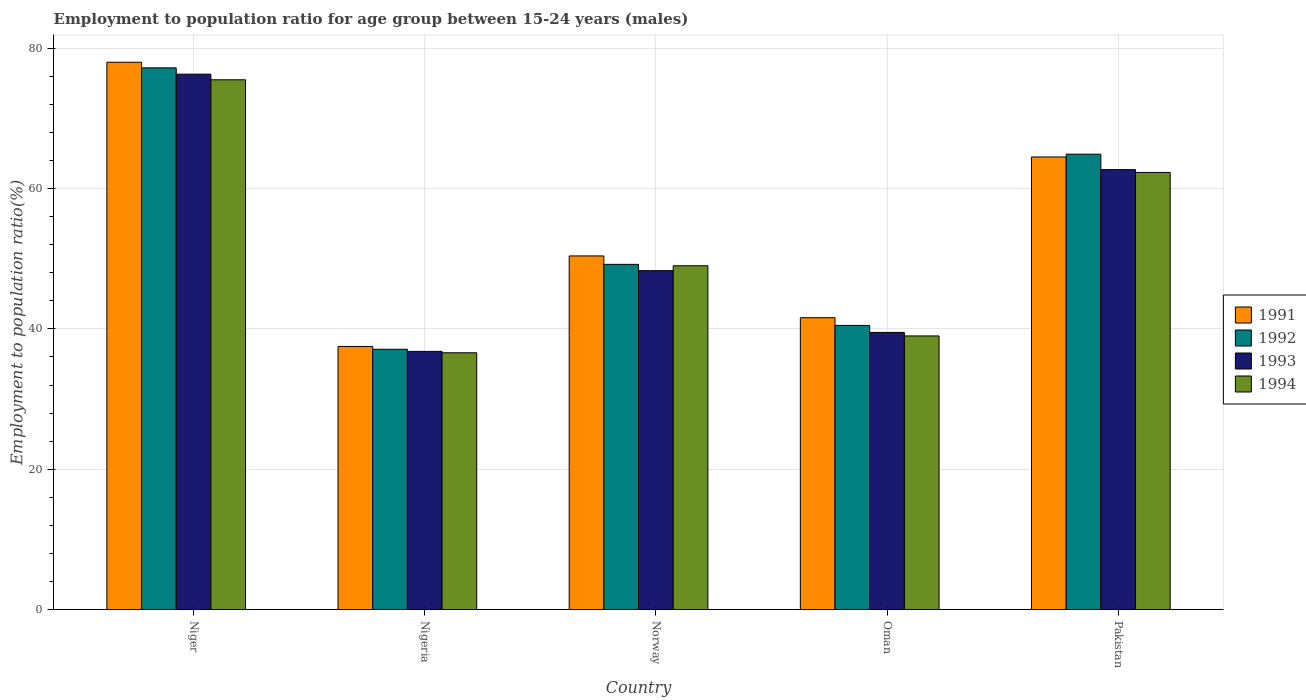How many different coloured bars are there?
Your answer should be very brief. 4. How many groups of bars are there?
Make the answer very short. 5. What is the label of the 4th group of bars from the left?
Offer a terse response. Oman. In how many cases, is the number of bars for a given country not equal to the number of legend labels?
Provide a succinct answer. 0. What is the employment to population ratio in 1992 in Niger?
Ensure brevity in your answer.  77.2. Across all countries, what is the maximum employment to population ratio in 1994?
Your answer should be compact. 75.5. Across all countries, what is the minimum employment to population ratio in 1994?
Make the answer very short. 36.6. In which country was the employment to population ratio in 1992 maximum?
Ensure brevity in your answer.  Niger. In which country was the employment to population ratio in 1991 minimum?
Your answer should be very brief. Nigeria. What is the total employment to population ratio in 1991 in the graph?
Your response must be concise. 272. What is the difference between the employment to population ratio in 1993 in Nigeria and that in Oman?
Make the answer very short. -2.7. What is the difference between the employment to population ratio in 1994 in Pakistan and the employment to population ratio in 1991 in Niger?
Keep it short and to the point. -15.7. What is the average employment to population ratio in 1992 per country?
Your answer should be compact. 53.78. What is the difference between the employment to population ratio of/in 1994 and employment to population ratio of/in 1991 in Nigeria?
Keep it short and to the point. -0.9. What is the ratio of the employment to population ratio in 1992 in Nigeria to that in Pakistan?
Your answer should be very brief. 0.57. Is the employment to population ratio in 1994 in Oman less than that in Pakistan?
Offer a terse response. Yes. What is the difference between the highest and the second highest employment to population ratio in 1993?
Your answer should be very brief. -28. What is the difference between the highest and the lowest employment to population ratio in 1992?
Your answer should be very brief. 40.1. Is it the case that in every country, the sum of the employment to population ratio in 1991 and employment to population ratio in 1993 is greater than the sum of employment to population ratio in 1992 and employment to population ratio in 1994?
Offer a very short reply. No. What does the 3rd bar from the left in Pakistan represents?
Give a very brief answer. 1993. Is it the case that in every country, the sum of the employment to population ratio in 1991 and employment to population ratio in 1993 is greater than the employment to population ratio in 1994?
Your answer should be very brief. Yes. Are all the bars in the graph horizontal?
Make the answer very short. No. How many countries are there in the graph?
Your answer should be very brief. 5. What is the difference between two consecutive major ticks on the Y-axis?
Offer a terse response. 20. Where does the legend appear in the graph?
Provide a short and direct response. Center right. How many legend labels are there?
Give a very brief answer. 4. What is the title of the graph?
Your answer should be compact. Employment to population ratio for age group between 15-24 years (males). What is the label or title of the X-axis?
Give a very brief answer. Country. What is the Employment to population ratio(%) of 1992 in Niger?
Ensure brevity in your answer.  77.2. What is the Employment to population ratio(%) of 1993 in Niger?
Your answer should be very brief. 76.3. What is the Employment to population ratio(%) in 1994 in Niger?
Give a very brief answer. 75.5. What is the Employment to population ratio(%) of 1991 in Nigeria?
Keep it short and to the point. 37.5. What is the Employment to population ratio(%) of 1992 in Nigeria?
Offer a terse response. 37.1. What is the Employment to population ratio(%) in 1993 in Nigeria?
Provide a succinct answer. 36.8. What is the Employment to population ratio(%) in 1994 in Nigeria?
Your answer should be very brief. 36.6. What is the Employment to population ratio(%) of 1991 in Norway?
Your response must be concise. 50.4. What is the Employment to population ratio(%) of 1992 in Norway?
Ensure brevity in your answer.  49.2. What is the Employment to population ratio(%) of 1993 in Norway?
Your answer should be compact. 48.3. What is the Employment to population ratio(%) of 1991 in Oman?
Provide a succinct answer. 41.6. What is the Employment to population ratio(%) of 1992 in Oman?
Keep it short and to the point. 40.5. What is the Employment to population ratio(%) in 1993 in Oman?
Provide a short and direct response. 39.5. What is the Employment to population ratio(%) in 1994 in Oman?
Offer a very short reply. 39. What is the Employment to population ratio(%) of 1991 in Pakistan?
Your response must be concise. 64.5. What is the Employment to population ratio(%) in 1992 in Pakistan?
Keep it short and to the point. 64.9. What is the Employment to population ratio(%) in 1993 in Pakistan?
Give a very brief answer. 62.7. What is the Employment to population ratio(%) in 1994 in Pakistan?
Your response must be concise. 62.3. Across all countries, what is the maximum Employment to population ratio(%) in 1991?
Offer a terse response. 78. Across all countries, what is the maximum Employment to population ratio(%) in 1992?
Provide a succinct answer. 77.2. Across all countries, what is the maximum Employment to population ratio(%) of 1993?
Provide a short and direct response. 76.3. Across all countries, what is the maximum Employment to population ratio(%) of 1994?
Keep it short and to the point. 75.5. Across all countries, what is the minimum Employment to population ratio(%) in 1991?
Your answer should be very brief. 37.5. Across all countries, what is the minimum Employment to population ratio(%) of 1992?
Ensure brevity in your answer.  37.1. Across all countries, what is the minimum Employment to population ratio(%) of 1993?
Make the answer very short. 36.8. Across all countries, what is the minimum Employment to population ratio(%) of 1994?
Offer a terse response. 36.6. What is the total Employment to population ratio(%) of 1991 in the graph?
Make the answer very short. 272. What is the total Employment to population ratio(%) of 1992 in the graph?
Provide a short and direct response. 268.9. What is the total Employment to population ratio(%) of 1993 in the graph?
Your response must be concise. 263.6. What is the total Employment to population ratio(%) of 1994 in the graph?
Keep it short and to the point. 262.4. What is the difference between the Employment to population ratio(%) in 1991 in Niger and that in Nigeria?
Your answer should be very brief. 40.5. What is the difference between the Employment to population ratio(%) of 1992 in Niger and that in Nigeria?
Provide a short and direct response. 40.1. What is the difference between the Employment to population ratio(%) of 1993 in Niger and that in Nigeria?
Your answer should be compact. 39.5. What is the difference between the Employment to population ratio(%) of 1994 in Niger and that in Nigeria?
Offer a very short reply. 38.9. What is the difference between the Employment to population ratio(%) in 1991 in Niger and that in Norway?
Offer a very short reply. 27.6. What is the difference between the Employment to population ratio(%) of 1992 in Niger and that in Norway?
Provide a short and direct response. 28. What is the difference between the Employment to population ratio(%) of 1993 in Niger and that in Norway?
Your answer should be very brief. 28. What is the difference between the Employment to population ratio(%) in 1994 in Niger and that in Norway?
Offer a very short reply. 26.5. What is the difference between the Employment to population ratio(%) in 1991 in Niger and that in Oman?
Ensure brevity in your answer.  36.4. What is the difference between the Employment to population ratio(%) of 1992 in Niger and that in Oman?
Provide a succinct answer. 36.7. What is the difference between the Employment to population ratio(%) in 1993 in Niger and that in Oman?
Offer a very short reply. 36.8. What is the difference between the Employment to population ratio(%) in 1994 in Niger and that in Oman?
Offer a very short reply. 36.5. What is the difference between the Employment to population ratio(%) in 1992 in Niger and that in Pakistan?
Offer a terse response. 12.3. What is the difference between the Employment to population ratio(%) in 1994 in Niger and that in Pakistan?
Keep it short and to the point. 13.2. What is the difference between the Employment to population ratio(%) of 1992 in Nigeria and that in Norway?
Your response must be concise. -12.1. What is the difference between the Employment to population ratio(%) of 1994 in Nigeria and that in Norway?
Make the answer very short. -12.4. What is the difference between the Employment to population ratio(%) of 1992 in Nigeria and that in Oman?
Your answer should be compact. -3.4. What is the difference between the Employment to population ratio(%) in 1994 in Nigeria and that in Oman?
Ensure brevity in your answer.  -2.4. What is the difference between the Employment to population ratio(%) of 1992 in Nigeria and that in Pakistan?
Your answer should be very brief. -27.8. What is the difference between the Employment to population ratio(%) of 1993 in Nigeria and that in Pakistan?
Give a very brief answer. -25.9. What is the difference between the Employment to population ratio(%) in 1994 in Nigeria and that in Pakistan?
Keep it short and to the point. -25.7. What is the difference between the Employment to population ratio(%) in 1992 in Norway and that in Oman?
Offer a terse response. 8.7. What is the difference between the Employment to population ratio(%) in 1993 in Norway and that in Oman?
Make the answer very short. 8.8. What is the difference between the Employment to population ratio(%) of 1994 in Norway and that in Oman?
Your response must be concise. 10. What is the difference between the Employment to population ratio(%) of 1991 in Norway and that in Pakistan?
Keep it short and to the point. -14.1. What is the difference between the Employment to population ratio(%) of 1992 in Norway and that in Pakistan?
Provide a succinct answer. -15.7. What is the difference between the Employment to population ratio(%) of 1993 in Norway and that in Pakistan?
Offer a very short reply. -14.4. What is the difference between the Employment to population ratio(%) in 1994 in Norway and that in Pakistan?
Ensure brevity in your answer.  -13.3. What is the difference between the Employment to population ratio(%) of 1991 in Oman and that in Pakistan?
Make the answer very short. -22.9. What is the difference between the Employment to population ratio(%) in 1992 in Oman and that in Pakistan?
Your response must be concise. -24.4. What is the difference between the Employment to population ratio(%) in 1993 in Oman and that in Pakistan?
Provide a succinct answer. -23.2. What is the difference between the Employment to population ratio(%) of 1994 in Oman and that in Pakistan?
Your response must be concise. -23.3. What is the difference between the Employment to population ratio(%) of 1991 in Niger and the Employment to population ratio(%) of 1992 in Nigeria?
Offer a terse response. 40.9. What is the difference between the Employment to population ratio(%) in 1991 in Niger and the Employment to population ratio(%) in 1993 in Nigeria?
Keep it short and to the point. 41.2. What is the difference between the Employment to population ratio(%) of 1991 in Niger and the Employment to population ratio(%) of 1994 in Nigeria?
Offer a terse response. 41.4. What is the difference between the Employment to population ratio(%) in 1992 in Niger and the Employment to population ratio(%) in 1993 in Nigeria?
Offer a terse response. 40.4. What is the difference between the Employment to population ratio(%) of 1992 in Niger and the Employment to population ratio(%) of 1994 in Nigeria?
Your answer should be very brief. 40.6. What is the difference between the Employment to population ratio(%) of 1993 in Niger and the Employment to population ratio(%) of 1994 in Nigeria?
Make the answer very short. 39.7. What is the difference between the Employment to population ratio(%) in 1991 in Niger and the Employment to population ratio(%) in 1992 in Norway?
Make the answer very short. 28.8. What is the difference between the Employment to population ratio(%) in 1991 in Niger and the Employment to population ratio(%) in 1993 in Norway?
Your response must be concise. 29.7. What is the difference between the Employment to population ratio(%) of 1991 in Niger and the Employment to population ratio(%) of 1994 in Norway?
Your answer should be very brief. 29. What is the difference between the Employment to population ratio(%) in 1992 in Niger and the Employment to population ratio(%) in 1993 in Norway?
Give a very brief answer. 28.9. What is the difference between the Employment to population ratio(%) in 1992 in Niger and the Employment to population ratio(%) in 1994 in Norway?
Make the answer very short. 28.2. What is the difference between the Employment to population ratio(%) of 1993 in Niger and the Employment to population ratio(%) of 1994 in Norway?
Offer a terse response. 27.3. What is the difference between the Employment to population ratio(%) in 1991 in Niger and the Employment to population ratio(%) in 1992 in Oman?
Offer a terse response. 37.5. What is the difference between the Employment to population ratio(%) in 1991 in Niger and the Employment to population ratio(%) in 1993 in Oman?
Provide a succinct answer. 38.5. What is the difference between the Employment to population ratio(%) of 1991 in Niger and the Employment to population ratio(%) of 1994 in Oman?
Provide a short and direct response. 39. What is the difference between the Employment to population ratio(%) of 1992 in Niger and the Employment to population ratio(%) of 1993 in Oman?
Keep it short and to the point. 37.7. What is the difference between the Employment to population ratio(%) in 1992 in Niger and the Employment to population ratio(%) in 1994 in Oman?
Provide a short and direct response. 38.2. What is the difference between the Employment to population ratio(%) of 1993 in Niger and the Employment to population ratio(%) of 1994 in Oman?
Offer a very short reply. 37.3. What is the difference between the Employment to population ratio(%) of 1991 in Niger and the Employment to population ratio(%) of 1992 in Pakistan?
Provide a short and direct response. 13.1. What is the difference between the Employment to population ratio(%) of 1991 in Niger and the Employment to population ratio(%) of 1993 in Pakistan?
Make the answer very short. 15.3. What is the difference between the Employment to population ratio(%) of 1991 in Niger and the Employment to population ratio(%) of 1994 in Pakistan?
Your answer should be compact. 15.7. What is the difference between the Employment to population ratio(%) in 1992 in Niger and the Employment to population ratio(%) in 1993 in Pakistan?
Offer a terse response. 14.5. What is the difference between the Employment to population ratio(%) of 1992 in Niger and the Employment to population ratio(%) of 1994 in Pakistan?
Your answer should be very brief. 14.9. What is the difference between the Employment to population ratio(%) in 1993 in Niger and the Employment to population ratio(%) in 1994 in Pakistan?
Offer a very short reply. 14. What is the difference between the Employment to population ratio(%) of 1991 in Nigeria and the Employment to population ratio(%) of 1992 in Norway?
Your response must be concise. -11.7. What is the difference between the Employment to population ratio(%) in 1991 in Nigeria and the Employment to population ratio(%) in 1993 in Norway?
Provide a succinct answer. -10.8. What is the difference between the Employment to population ratio(%) of 1991 in Nigeria and the Employment to population ratio(%) of 1994 in Norway?
Ensure brevity in your answer.  -11.5. What is the difference between the Employment to population ratio(%) in 1992 in Nigeria and the Employment to population ratio(%) in 1993 in Norway?
Keep it short and to the point. -11.2. What is the difference between the Employment to population ratio(%) of 1993 in Nigeria and the Employment to population ratio(%) of 1994 in Norway?
Offer a terse response. -12.2. What is the difference between the Employment to population ratio(%) of 1991 in Nigeria and the Employment to population ratio(%) of 1992 in Oman?
Your answer should be compact. -3. What is the difference between the Employment to population ratio(%) of 1991 in Nigeria and the Employment to population ratio(%) of 1994 in Oman?
Your response must be concise. -1.5. What is the difference between the Employment to population ratio(%) of 1992 in Nigeria and the Employment to population ratio(%) of 1994 in Oman?
Offer a terse response. -1.9. What is the difference between the Employment to population ratio(%) in 1991 in Nigeria and the Employment to population ratio(%) in 1992 in Pakistan?
Your answer should be very brief. -27.4. What is the difference between the Employment to population ratio(%) of 1991 in Nigeria and the Employment to population ratio(%) of 1993 in Pakistan?
Give a very brief answer. -25.2. What is the difference between the Employment to population ratio(%) of 1991 in Nigeria and the Employment to population ratio(%) of 1994 in Pakistan?
Your response must be concise. -24.8. What is the difference between the Employment to population ratio(%) in 1992 in Nigeria and the Employment to population ratio(%) in 1993 in Pakistan?
Provide a short and direct response. -25.6. What is the difference between the Employment to population ratio(%) of 1992 in Nigeria and the Employment to population ratio(%) of 1994 in Pakistan?
Offer a terse response. -25.2. What is the difference between the Employment to population ratio(%) of 1993 in Nigeria and the Employment to population ratio(%) of 1994 in Pakistan?
Offer a terse response. -25.5. What is the difference between the Employment to population ratio(%) of 1992 in Norway and the Employment to population ratio(%) of 1993 in Oman?
Your answer should be compact. 9.7. What is the difference between the Employment to population ratio(%) of 1992 in Norway and the Employment to population ratio(%) of 1994 in Oman?
Your response must be concise. 10.2. What is the difference between the Employment to population ratio(%) of 1993 in Norway and the Employment to population ratio(%) of 1994 in Oman?
Keep it short and to the point. 9.3. What is the difference between the Employment to population ratio(%) of 1991 in Norway and the Employment to population ratio(%) of 1992 in Pakistan?
Your answer should be compact. -14.5. What is the difference between the Employment to population ratio(%) in 1991 in Norway and the Employment to population ratio(%) in 1993 in Pakistan?
Provide a short and direct response. -12.3. What is the difference between the Employment to population ratio(%) of 1991 in Norway and the Employment to population ratio(%) of 1994 in Pakistan?
Offer a terse response. -11.9. What is the difference between the Employment to population ratio(%) in 1992 in Norway and the Employment to population ratio(%) in 1994 in Pakistan?
Provide a succinct answer. -13.1. What is the difference between the Employment to population ratio(%) in 1993 in Norway and the Employment to population ratio(%) in 1994 in Pakistan?
Keep it short and to the point. -14. What is the difference between the Employment to population ratio(%) of 1991 in Oman and the Employment to population ratio(%) of 1992 in Pakistan?
Make the answer very short. -23.3. What is the difference between the Employment to population ratio(%) in 1991 in Oman and the Employment to population ratio(%) in 1993 in Pakistan?
Provide a succinct answer. -21.1. What is the difference between the Employment to population ratio(%) in 1991 in Oman and the Employment to population ratio(%) in 1994 in Pakistan?
Provide a succinct answer. -20.7. What is the difference between the Employment to population ratio(%) in 1992 in Oman and the Employment to population ratio(%) in 1993 in Pakistan?
Make the answer very short. -22.2. What is the difference between the Employment to population ratio(%) in 1992 in Oman and the Employment to population ratio(%) in 1994 in Pakistan?
Offer a very short reply. -21.8. What is the difference between the Employment to population ratio(%) in 1993 in Oman and the Employment to population ratio(%) in 1994 in Pakistan?
Your answer should be compact. -22.8. What is the average Employment to population ratio(%) in 1991 per country?
Keep it short and to the point. 54.4. What is the average Employment to population ratio(%) in 1992 per country?
Keep it short and to the point. 53.78. What is the average Employment to population ratio(%) in 1993 per country?
Offer a terse response. 52.72. What is the average Employment to population ratio(%) of 1994 per country?
Provide a short and direct response. 52.48. What is the difference between the Employment to population ratio(%) of 1991 and Employment to population ratio(%) of 1992 in Niger?
Give a very brief answer. 0.8. What is the difference between the Employment to population ratio(%) of 1991 and Employment to population ratio(%) of 1994 in Niger?
Your answer should be compact. 2.5. What is the difference between the Employment to population ratio(%) of 1991 and Employment to population ratio(%) of 1993 in Nigeria?
Offer a very short reply. 0.7. What is the difference between the Employment to population ratio(%) of 1991 and Employment to population ratio(%) of 1994 in Nigeria?
Your answer should be compact. 0.9. What is the difference between the Employment to population ratio(%) in 1992 and Employment to population ratio(%) in 1994 in Nigeria?
Keep it short and to the point. 0.5. What is the difference between the Employment to population ratio(%) of 1991 and Employment to population ratio(%) of 1992 in Norway?
Provide a short and direct response. 1.2. What is the difference between the Employment to population ratio(%) in 1991 and Employment to population ratio(%) in 1993 in Norway?
Offer a very short reply. 2.1. What is the difference between the Employment to population ratio(%) of 1991 and Employment to population ratio(%) of 1994 in Norway?
Your answer should be compact. 1.4. What is the difference between the Employment to population ratio(%) of 1992 and Employment to population ratio(%) of 1994 in Norway?
Keep it short and to the point. 0.2. What is the difference between the Employment to population ratio(%) of 1991 and Employment to population ratio(%) of 1992 in Oman?
Keep it short and to the point. 1.1. What is the difference between the Employment to population ratio(%) of 1992 and Employment to population ratio(%) of 1993 in Oman?
Offer a terse response. 1. What is the difference between the Employment to population ratio(%) in 1992 and Employment to population ratio(%) in 1994 in Oman?
Provide a succinct answer. 1.5. What is the difference between the Employment to population ratio(%) in 1993 and Employment to population ratio(%) in 1994 in Oman?
Your response must be concise. 0.5. What is the difference between the Employment to population ratio(%) of 1991 and Employment to population ratio(%) of 1992 in Pakistan?
Ensure brevity in your answer.  -0.4. What is the difference between the Employment to population ratio(%) of 1991 and Employment to population ratio(%) of 1994 in Pakistan?
Your answer should be very brief. 2.2. What is the difference between the Employment to population ratio(%) of 1992 and Employment to population ratio(%) of 1993 in Pakistan?
Offer a terse response. 2.2. What is the ratio of the Employment to population ratio(%) of 1991 in Niger to that in Nigeria?
Provide a succinct answer. 2.08. What is the ratio of the Employment to population ratio(%) in 1992 in Niger to that in Nigeria?
Ensure brevity in your answer.  2.08. What is the ratio of the Employment to population ratio(%) in 1993 in Niger to that in Nigeria?
Your response must be concise. 2.07. What is the ratio of the Employment to population ratio(%) in 1994 in Niger to that in Nigeria?
Your answer should be very brief. 2.06. What is the ratio of the Employment to population ratio(%) of 1991 in Niger to that in Norway?
Your response must be concise. 1.55. What is the ratio of the Employment to population ratio(%) of 1992 in Niger to that in Norway?
Give a very brief answer. 1.57. What is the ratio of the Employment to population ratio(%) of 1993 in Niger to that in Norway?
Your answer should be very brief. 1.58. What is the ratio of the Employment to population ratio(%) of 1994 in Niger to that in Norway?
Ensure brevity in your answer.  1.54. What is the ratio of the Employment to population ratio(%) of 1991 in Niger to that in Oman?
Make the answer very short. 1.88. What is the ratio of the Employment to population ratio(%) of 1992 in Niger to that in Oman?
Offer a very short reply. 1.91. What is the ratio of the Employment to population ratio(%) of 1993 in Niger to that in Oman?
Make the answer very short. 1.93. What is the ratio of the Employment to population ratio(%) in 1994 in Niger to that in Oman?
Ensure brevity in your answer.  1.94. What is the ratio of the Employment to population ratio(%) of 1991 in Niger to that in Pakistan?
Give a very brief answer. 1.21. What is the ratio of the Employment to population ratio(%) of 1992 in Niger to that in Pakistan?
Your answer should be compact. 1.19. What is the ratio of the Employment to population ratio(%) of 1993 in Niger to that in Pakistan?
Your response must be concise. 1.22. What is the ratio of the Employment to population ratio(%) in 1994 in Niger to that in Pakistan?
Your response must be concise. 1.21. What is the ratio of the Employment to population ratio(%) of 1991 in Nigeria to that in Norway?
Provide a succinct answer. 0.74. What is the ratio of the Employment to population ratio(%) in 1992 in Nigeria to that in Norway?
Offer a very short reply. 0.75. What is the ratio of the Employment to population ratio(%) of 1993 in Nigeria to that in Norway?
Give a very brief answer. 0.76. What is the ratio of the Employment to population ratio(%) of 1994 in Nigeria to that in Norway?
Give a very brief answer. 0.75. What is the ratio of the Employment to population ratio(%) in 1991 in Nigeria to that in Oman?
Ensure brevity in your answer.  0.9. What is the ratio of the Employment to population ratio(%) of 1992 in Nigeria to that in Oman?
Ensure brevity in your answer.  0.92. What is the ratio of the Employment to population ratio(%) in 1993 in Nigeria to that in Oman?
Offer a very short reply. 0.93. What is the ratio of the Employment to population ratio(%) of 1994 in Nigeria to that in Oman?
Your response must be concise. 0.94. What is the ratio of the Employment to population ratio(%) in 1991 in Nigeria to that in Pakistan?
Offer a terse response. 0.58. What is the ratio of the Employment to population ratio(%) of 1992 in Nigeria to that in Pakistan?
Offer a very short reply. 0.57. What is the ratio of the Employment to population ratio(%) of 1993 in Nigeria to that in Pakistan?
Ensure brevity in your answer.  0.59. What is the ratio of the Employment to population ratio(%) in 1994 in Nigeria to that in Pakistan?
Your response must be concise. 0.59. What is the ratio of the Employment to population ratio(%) of 1991 in Norway to that in Oman?
Your answer should be very brief. 1.21. What is the ratio of the Employment to population ratio(%) in 1992 in Norway to that in Oman?
Offer a very short reply. 1.21. What is the ratio of the Employment to population ratio(%) of 1993 in Norway to that in Oman?
Make the answer very short. 1.22. What is the ratio of the Employment to population ratio(%) in 1994 in Norway to that in Oman?
Offer a very short reply. 1.26. What is the ratio of the Employment to population ratio(%) of 1991 in Norway to that in Pakistan?
Ensure brevity in your answer.  0.78. What is the ratio of the Employment to population ratio(%) in 1992 in Norway to that in Pakistan?
Make the answer very short. 0.76. What is the ratio of the Employment to population ratio(%) of 1993 in Norway to that in Pakistan?
Make the answer very short. 0.77. What is the ratio of the Employment to population ratio(%) in 1994 in Norway to that in Pakistan?
Your response must be concise. 0.79. What is the ratio of the Employment to population ratio(%) in 1991 in Oman to that in Pakistan?
Keep it short and to the point. 0.65. What is the ratio of the Employment to population ratio(%) of 1992 in Oman to that in Pakistan?
Provide a succinct answer. 0.62. What is the ratio of the Employment to population ratio(%) in 1993 in Oman to that in Pakistan?
Make the answer very short. 0.63. What is the ratio of the Employment to population ratio(%) in 1994 in Oman to that in Pakistan?
Give a very brief answer. 0.63. What is the difference between the highest and the second highest Employment to population ratio(%) in 1992?
Give a very brief answer. 12.3. What is the difference between the highest and the second highest Employment to population ratio(%) in 1994?
Give a very brief answer. 13.2. What is the difference between the highest and the lowest Employment to population ratio(%) of 1991?
Offer a terse response. 40.5. What is the difference between the highest and the lowest Employment to population ratio(%) of 1992?
Your answer should be very brief. 40.1. What is the difference between the highest and the lowest Employment to population ratio(%) of 1993?
Offer a terse response. 39.5. What is the difference between the highest and the lowest Employment to population ratio(%) of 1994?
Keep it short and to the point. 38.9. 